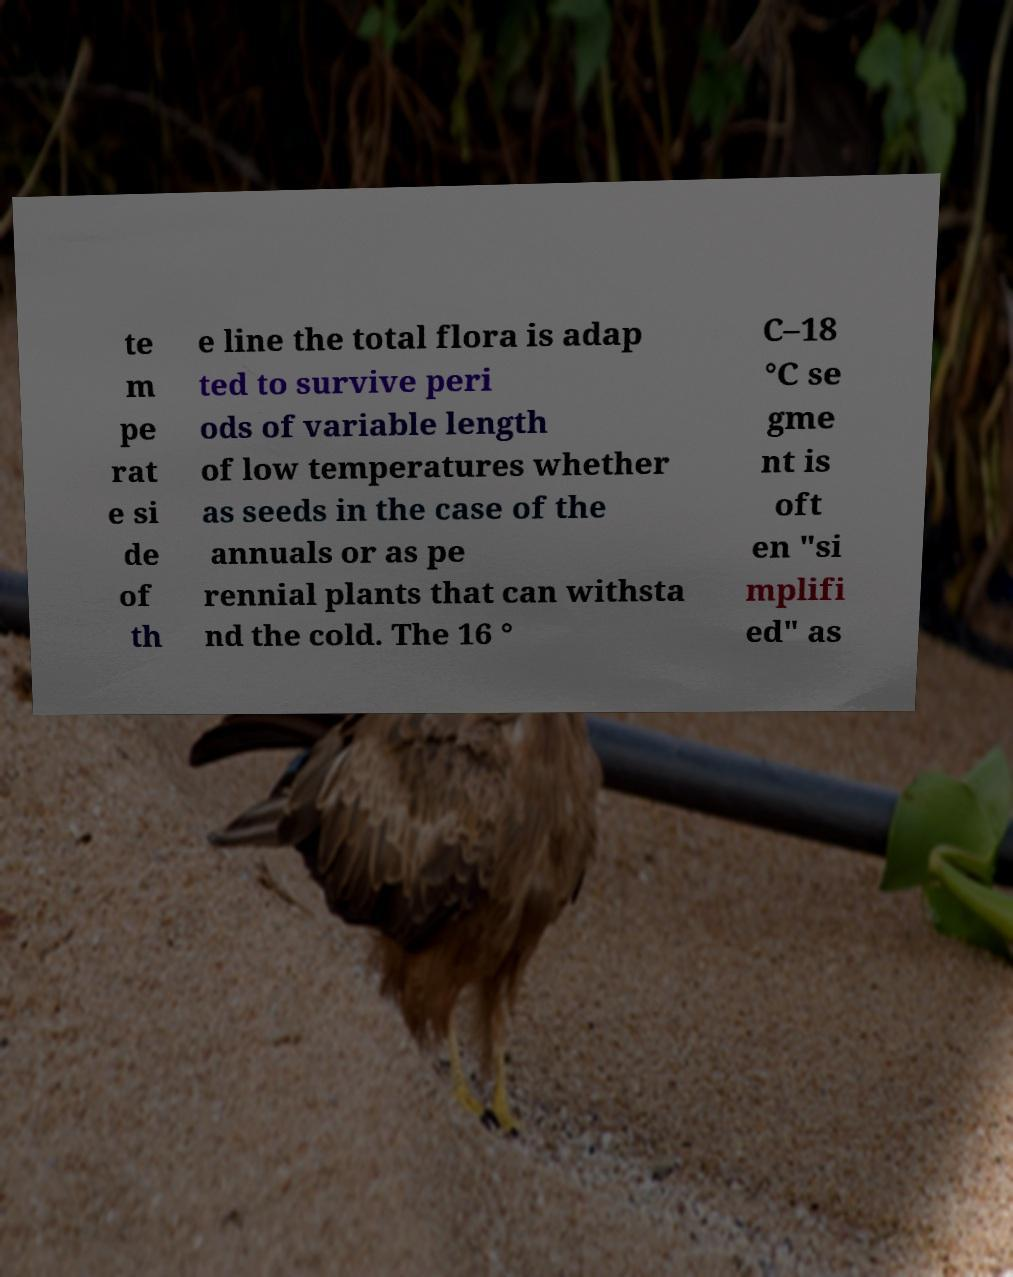Can you read and provide the text displayed in the image?This photo seems to have some interesting text. Can you extract and type it out for me? te m pe rat e si de of th e line the total flora is adap ted to survive peri ods of variable length of low temperatures whether as seeds in the case of the annuals or as pe rennial plants that can withsta nd the cold. The 16 ° C–18 °C se gme nt is oft en "si mplifi ed" as 